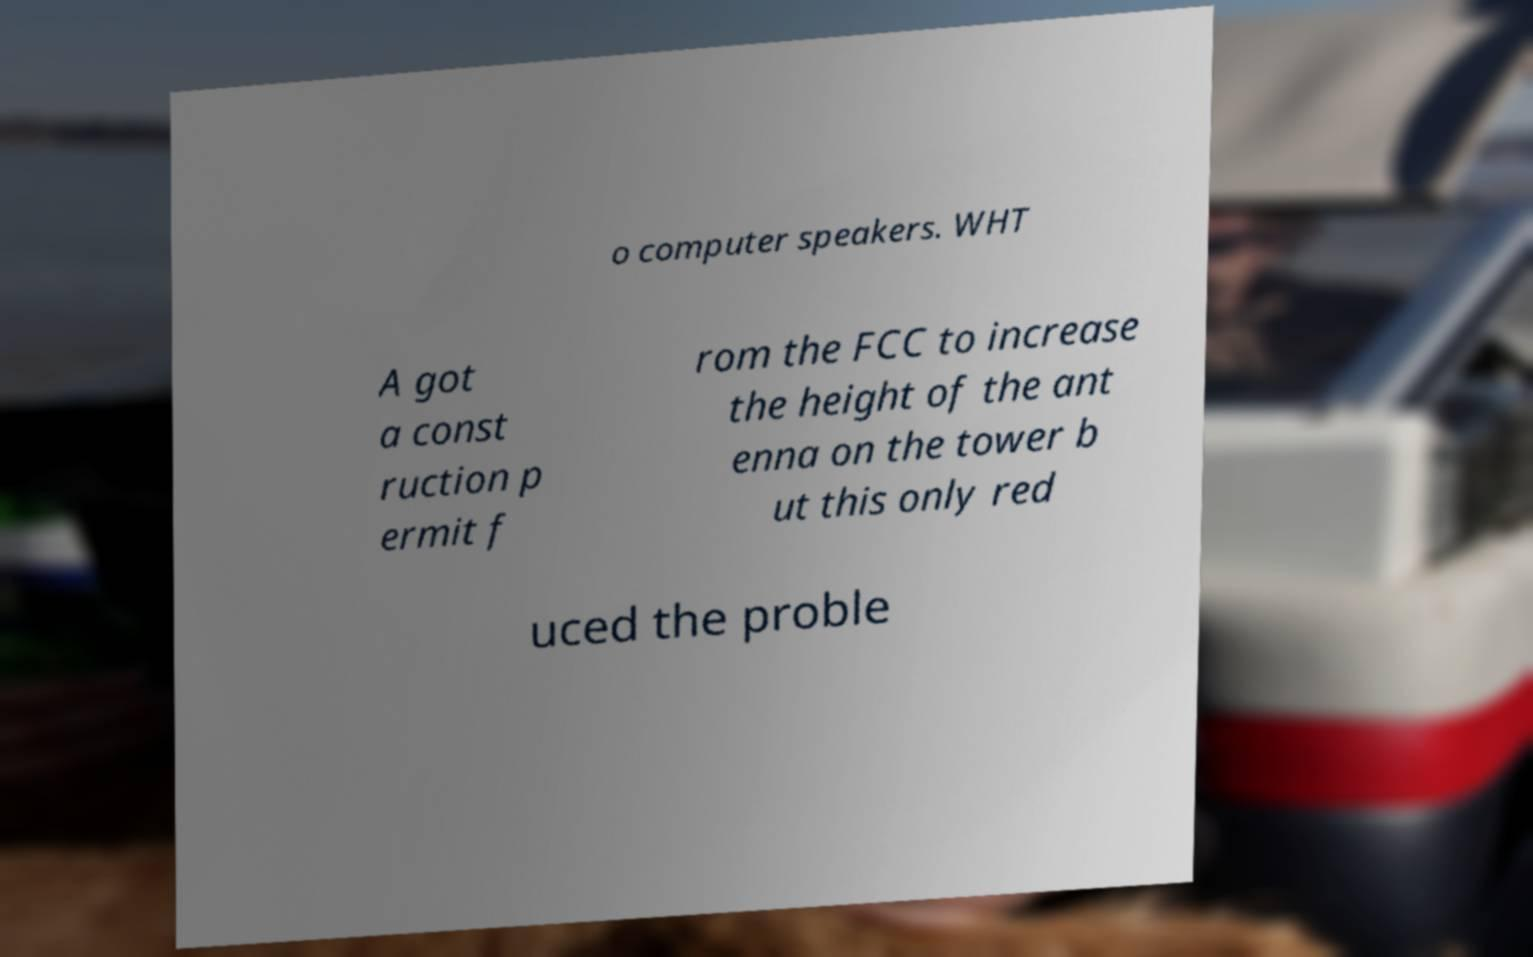What messages or text are displayed in this image? I need them in a readable, typed format. o computer speakers. WHT A got a const ruction p ermit f rom the FCC to increase the height of the ant enna on the tower b ut this only red uced the proble 